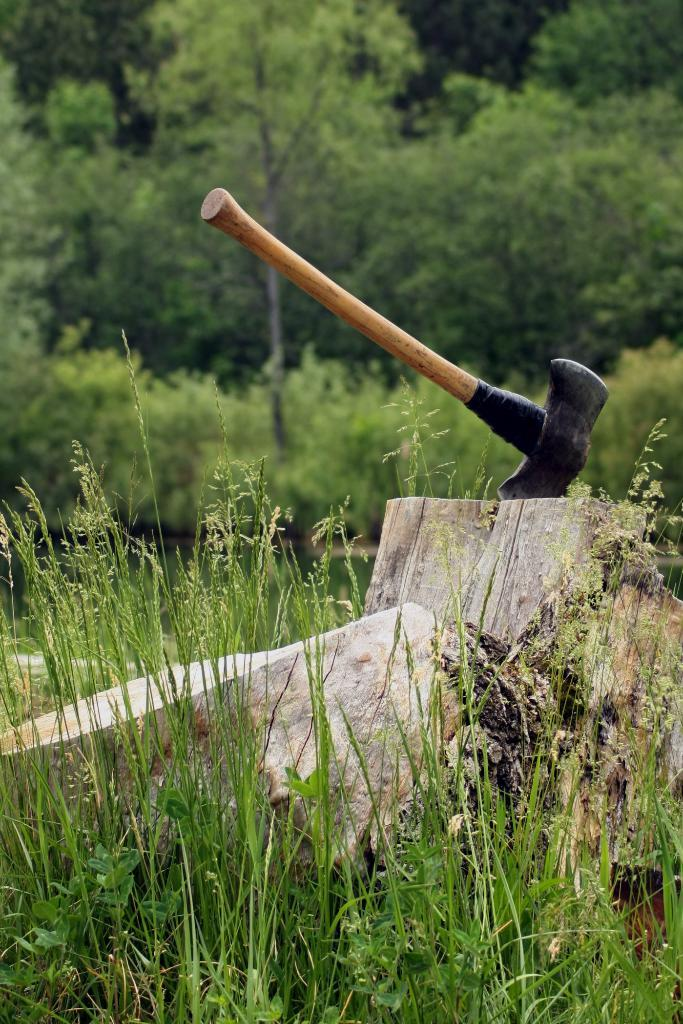What type of vegetation is at the bottom of the picture? There is grass at the bottom of the picture. What material is located in the middle of the picture? There is wood in the middle of the picture. What tool is also present in the middle of the picture? There is an axe in the middle of the picture. What can be seen in the background of the picture? There are trees in the background of the picture. How would you describe the background of the picture? The background of the picture is blurred. Can you see a boat in the picture? There is no boat present in the image. What type of stove is used in the picture? There is no stove present in the image. 